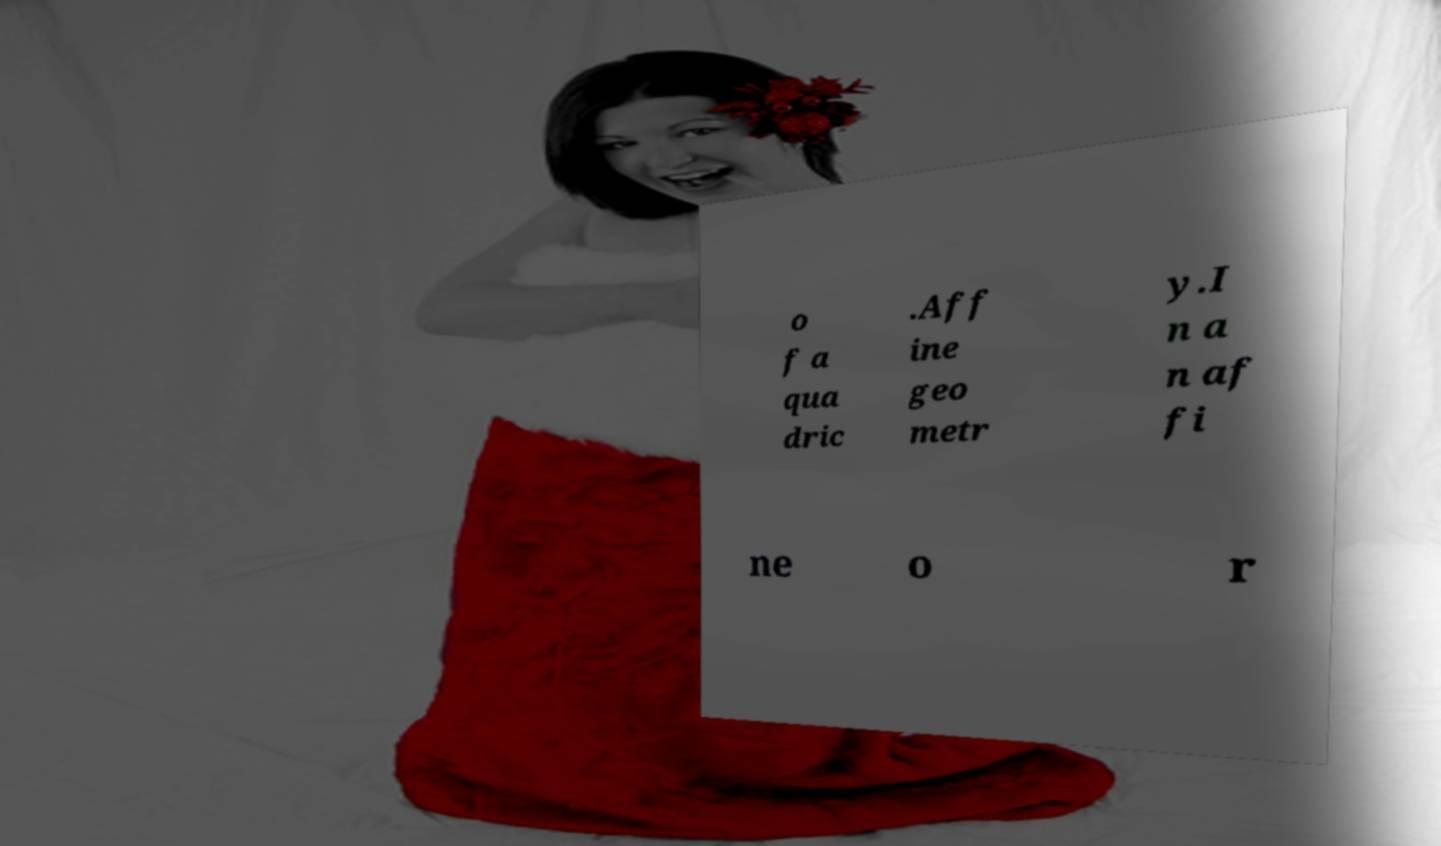Please read and relay the text visible in this image. What does it say? o f a qua dric .Aff ine geo metr y.I n a n af fi ne o r 